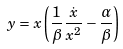Convert formula to latex. <formula><loc_0><loc_0><loc_500><loc_500>y = x \left ( \frac { 1 } { \beta } \frac { \dot { x } } { x ^ { 2 } } - \frac { \alpha } { \beta } \right )</formula> 